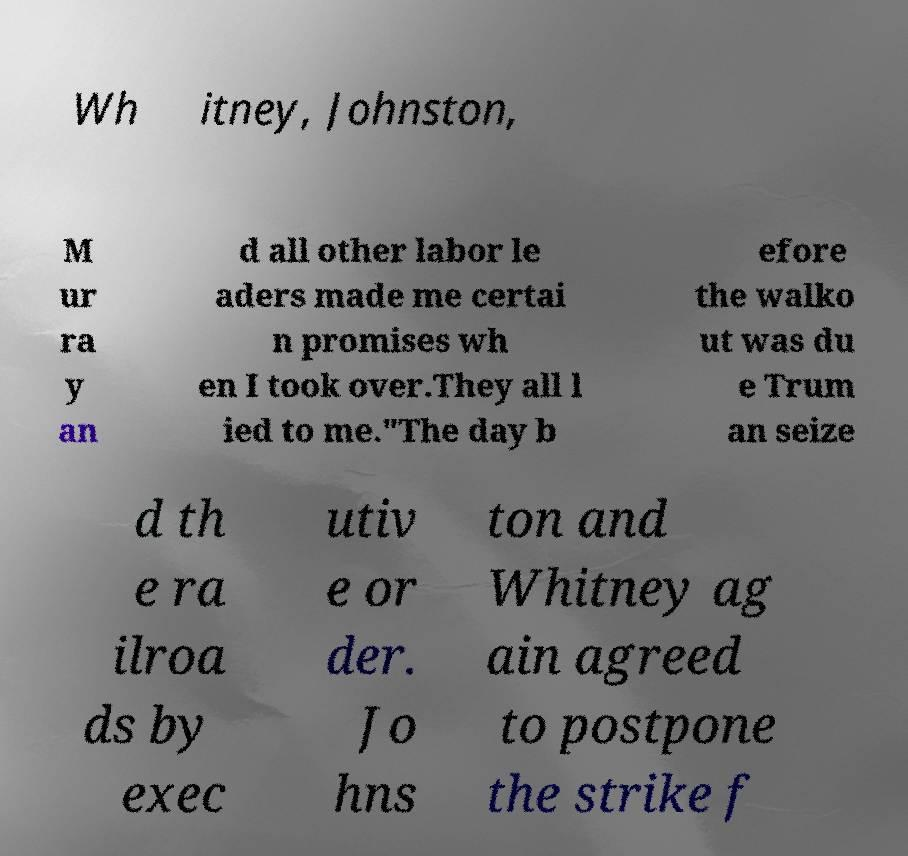Can you read and provide the text displayed in the image?This photo seems to have some interesting text. Can you extract and type it out for me? Wh itney, Johnston, M ur ra y an d all other labor le aders made me certai n promises wh en I took over.They all l ied to me."The day b efore the walko ut was du e Trum an seize d th e ra ilroa ds by exec utiv e or der. Jo hns ton and Whitney ag ain agreed to postpone the strike f 